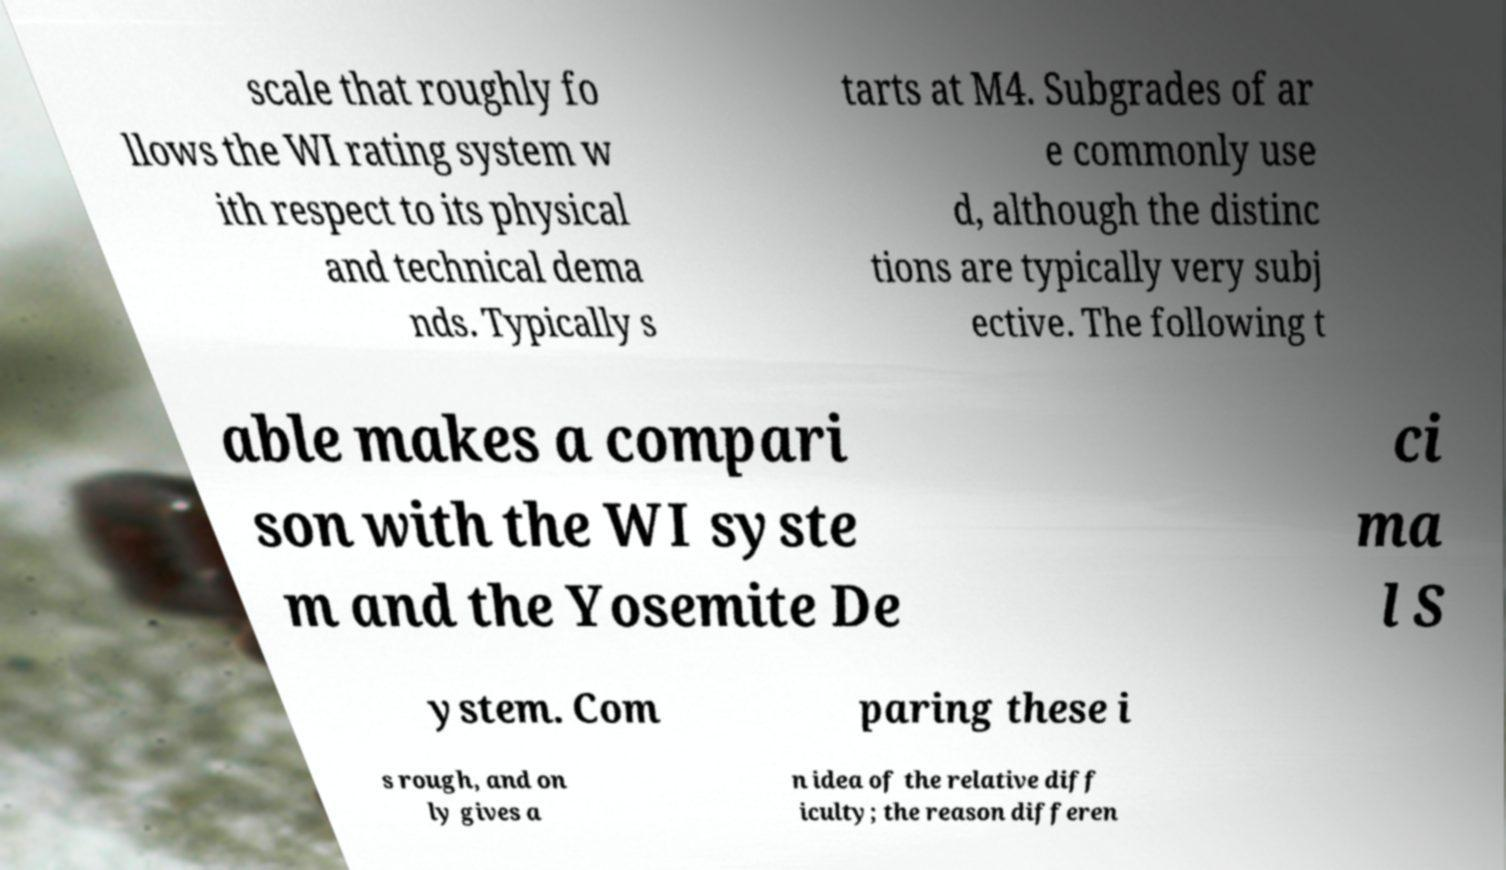Can you accurately transcribe the text from the provided image for me? scale that roughly fo llows the WI rating system w ith respect to its physical and technical dema nds. Typically s tarts at M4. Subgrades of ar e commonly use d, although the distinc tions are typically very subj ective. The following t able makes a compari son with the WI syste m and the Yosemite De ci ma l S ystem. Com paring these i s rough, and on ly gives a n idea of the relative diff iculty; the reason differen 